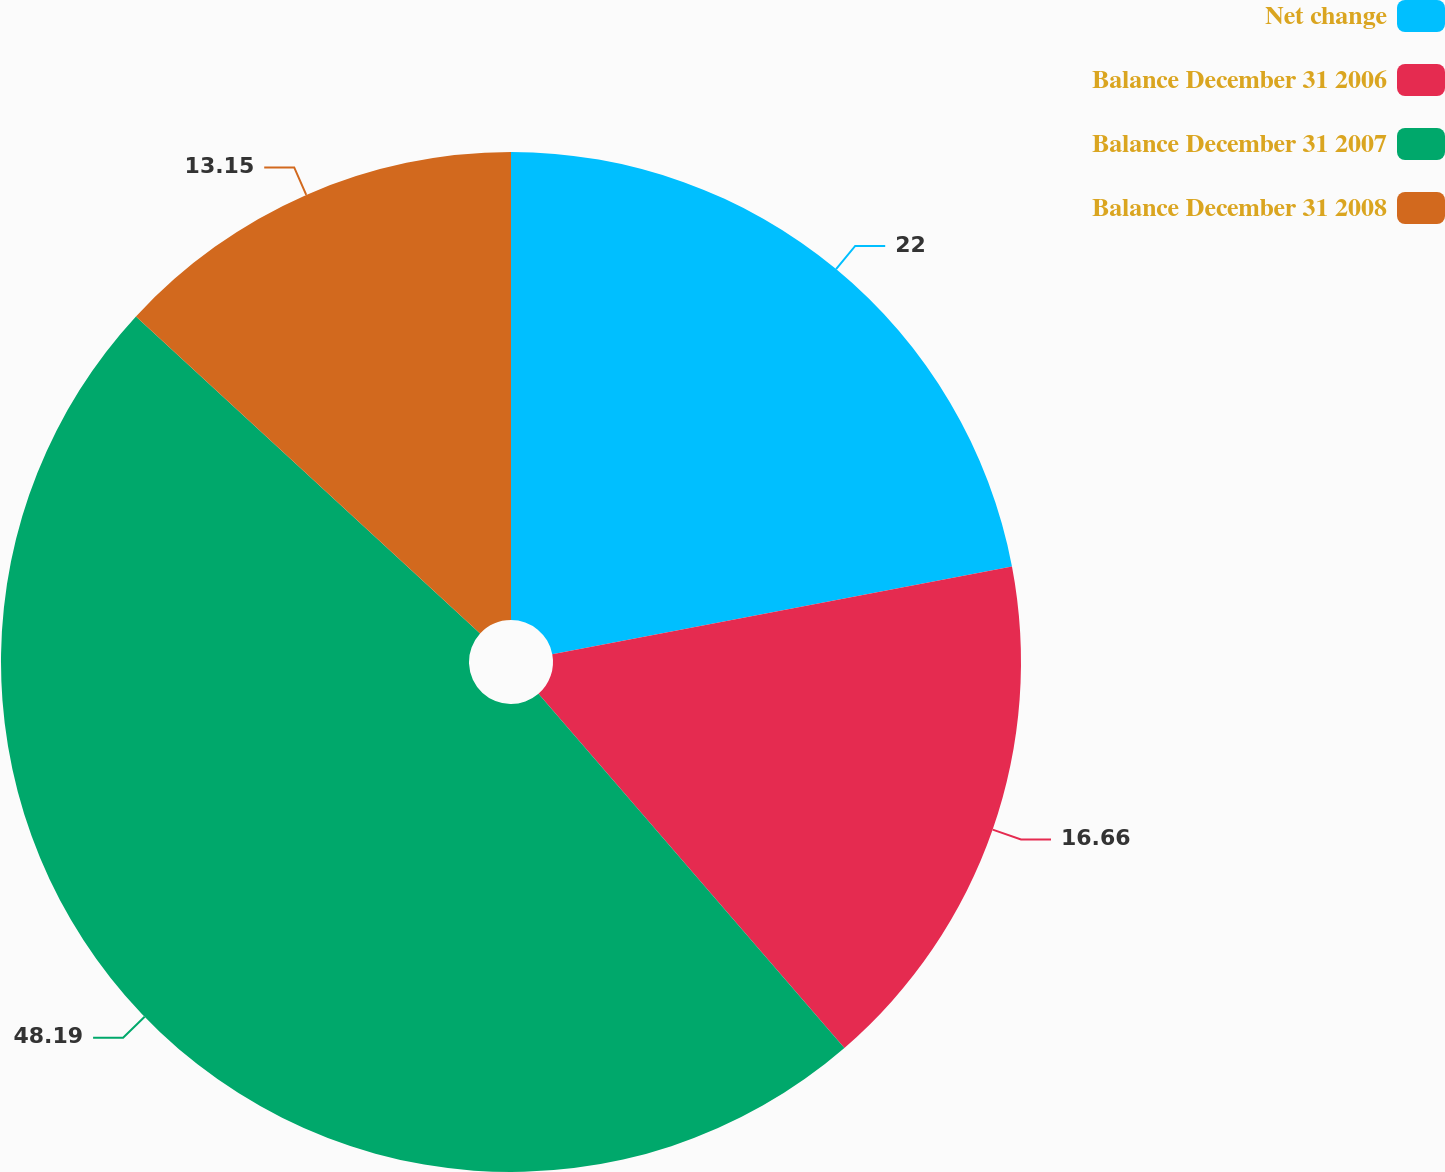Convert chart. <chart><loc_0><loc_0><loc_500><loc_500><pie_chart><fcel>Net change<fcel>Balance December 31 2006<fcel>Balance December 31 2007<fcel>Balance December 31 2008<nl><fcel>22.0%<fcel>16.66%<fcel>48.19%<fcel>13.15%<nl></chart> 